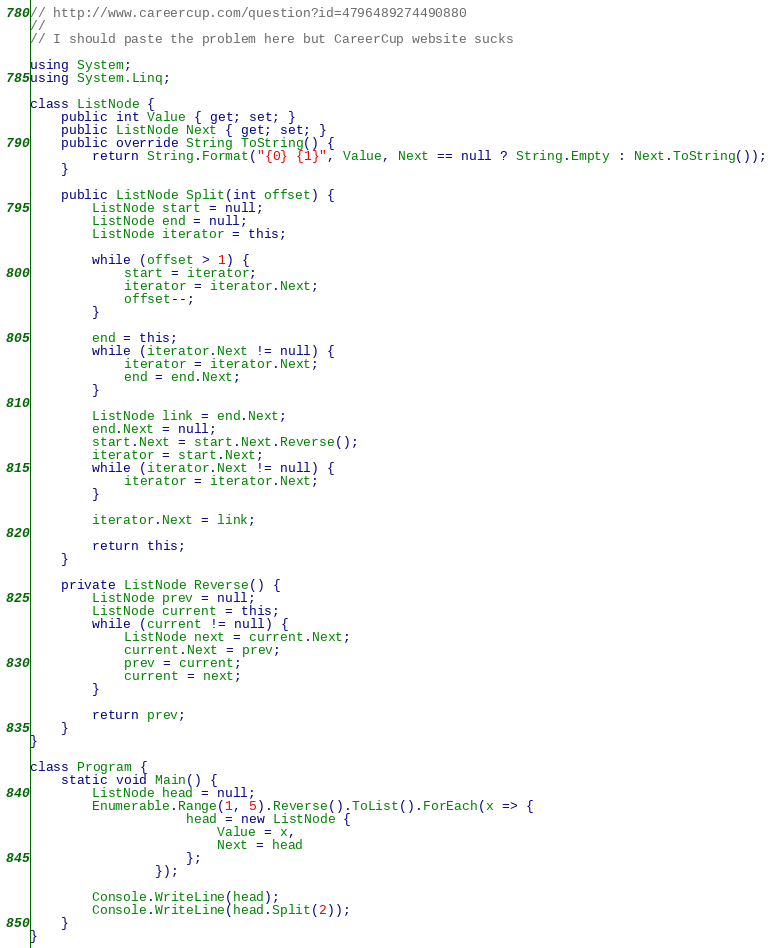Convert code to text. <code><loc_0><loc_0><loc_500><loc_500><_C#_>// http://www.careercup.com/question?id=4796489274490880
//
// I should paste the problem here but CareerCup website sucks

using System;
using System.Linq;

class ListNode {
    public int Value { get; set; }
    public ListNode Next { get; set; }
    public override String ToString() {
        return String.Format("{0} {1}", Value, Next == null ? String.Empty : Next.ToString());
    }

    public ListNode Split(int offset) {
        ListNode start = null;
        ListNode end = null;
        ListNode iterator = this;
        
        while (offset > 1) {
            start = iterator;
            iterator = iterator.Next;
            offset--;
        }

        end = this;
        while (iterator.Next != null) {
            iterator = iterator.Next;
            end = end.Next;
        }

        ListNode link = end.Next;
        end.Next = null;
        start.Next = start.Next.Reverse();
        iterator = start.Next;
        while (iterator.Next != null) {
            iterator = iterator.Next;
        }

        iterator.Next = link;
        
        return this;
    }

    private ListNode Reverse() {
        ListNode prev = null;
        ListNode current = this;
        while (current != null) {
            ListNode next = current.Next;
            current.Next = prev;
            prev = current;
            current = next;
        }

        return prev;
    }
}

class Program {
    static void Main() {
        ListNode head = null;
        Enumerable.Range(1, 5).Reverse().ToList().ForEach(x => {
                    head = new ListNode {
                        Value = x,
                        Next = head
                    };
                });

        Console.WriteLine(head);
        Console.WriteLine(head.Split(2));
    }
}
</code> 